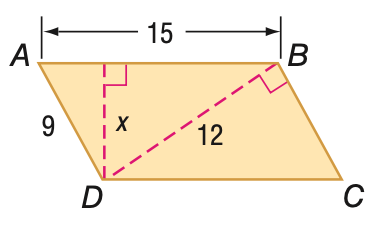Question: Find x in parallelogram A B C D.
Choices:
A. 5
B. 6
C. 7.2
D. 8.1
Answer with the letter. Answer: C 